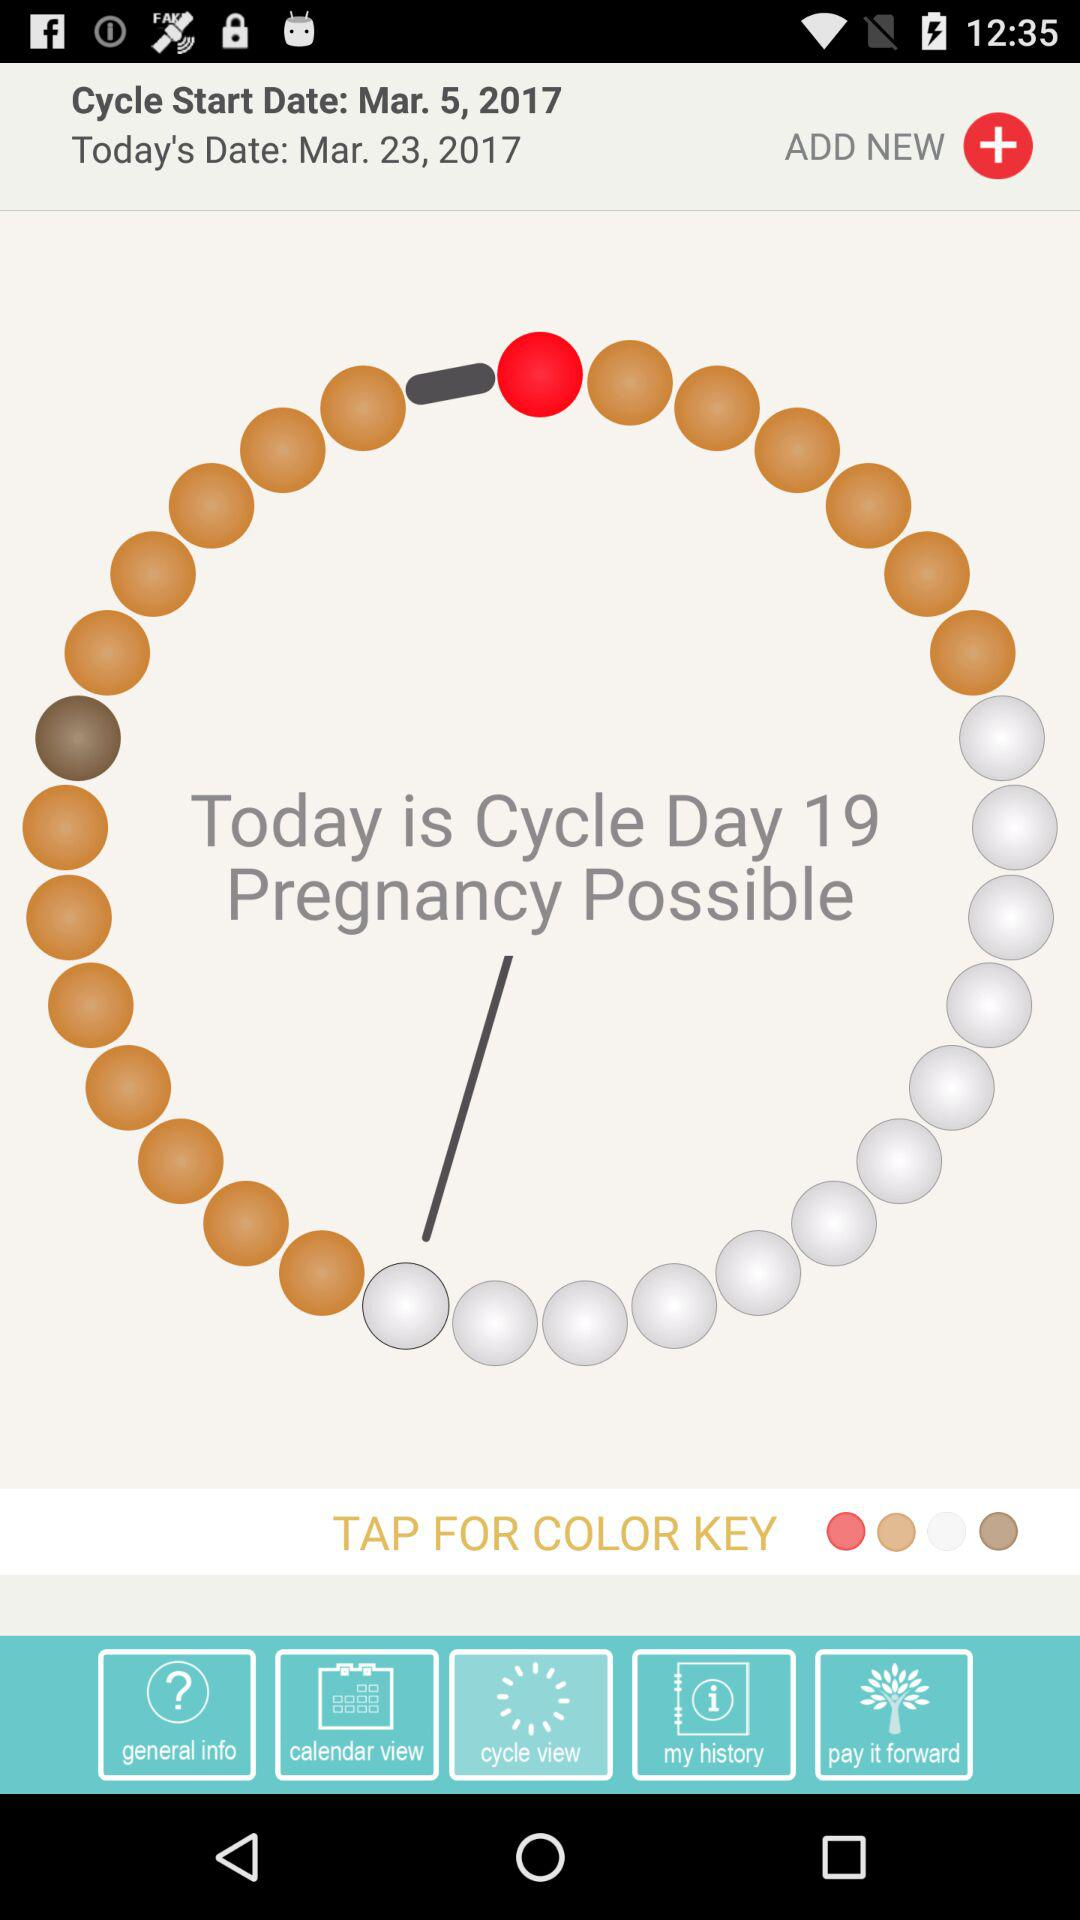What cycle day is it today? Today is cycle day 19. 